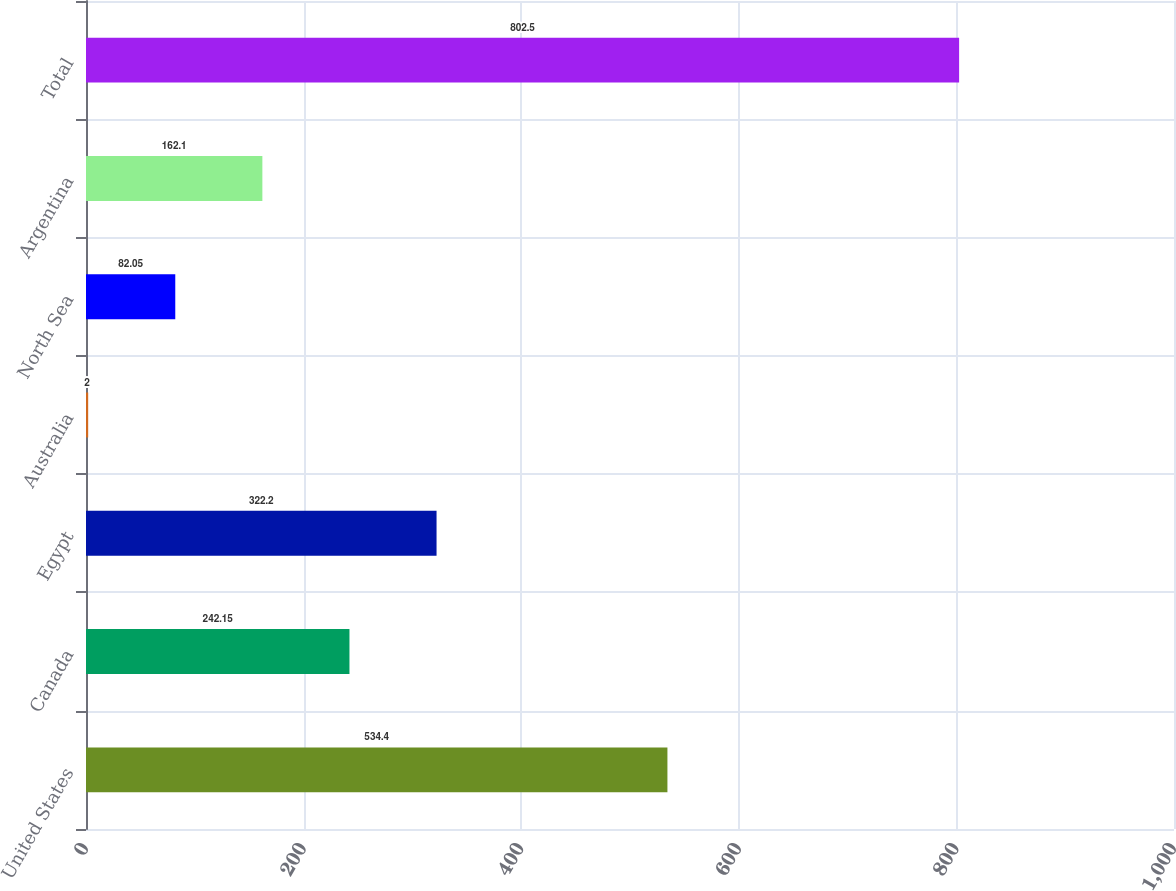Convert chart to OTSL. <chart><loc_0><loc_0><loc_500><loc_500><bar_chart><fcel>United States<fcel>Canada<fcel>Egypt<fcel>Australia<fcel>North Sea<fcel>Argentina<fcel>Total<nl><fcel>534.4<fcel>242.15<fcel>322.2<fcel>2<fcel>82.05<fcel>162.1<fcel>802.5<nl></chart> 